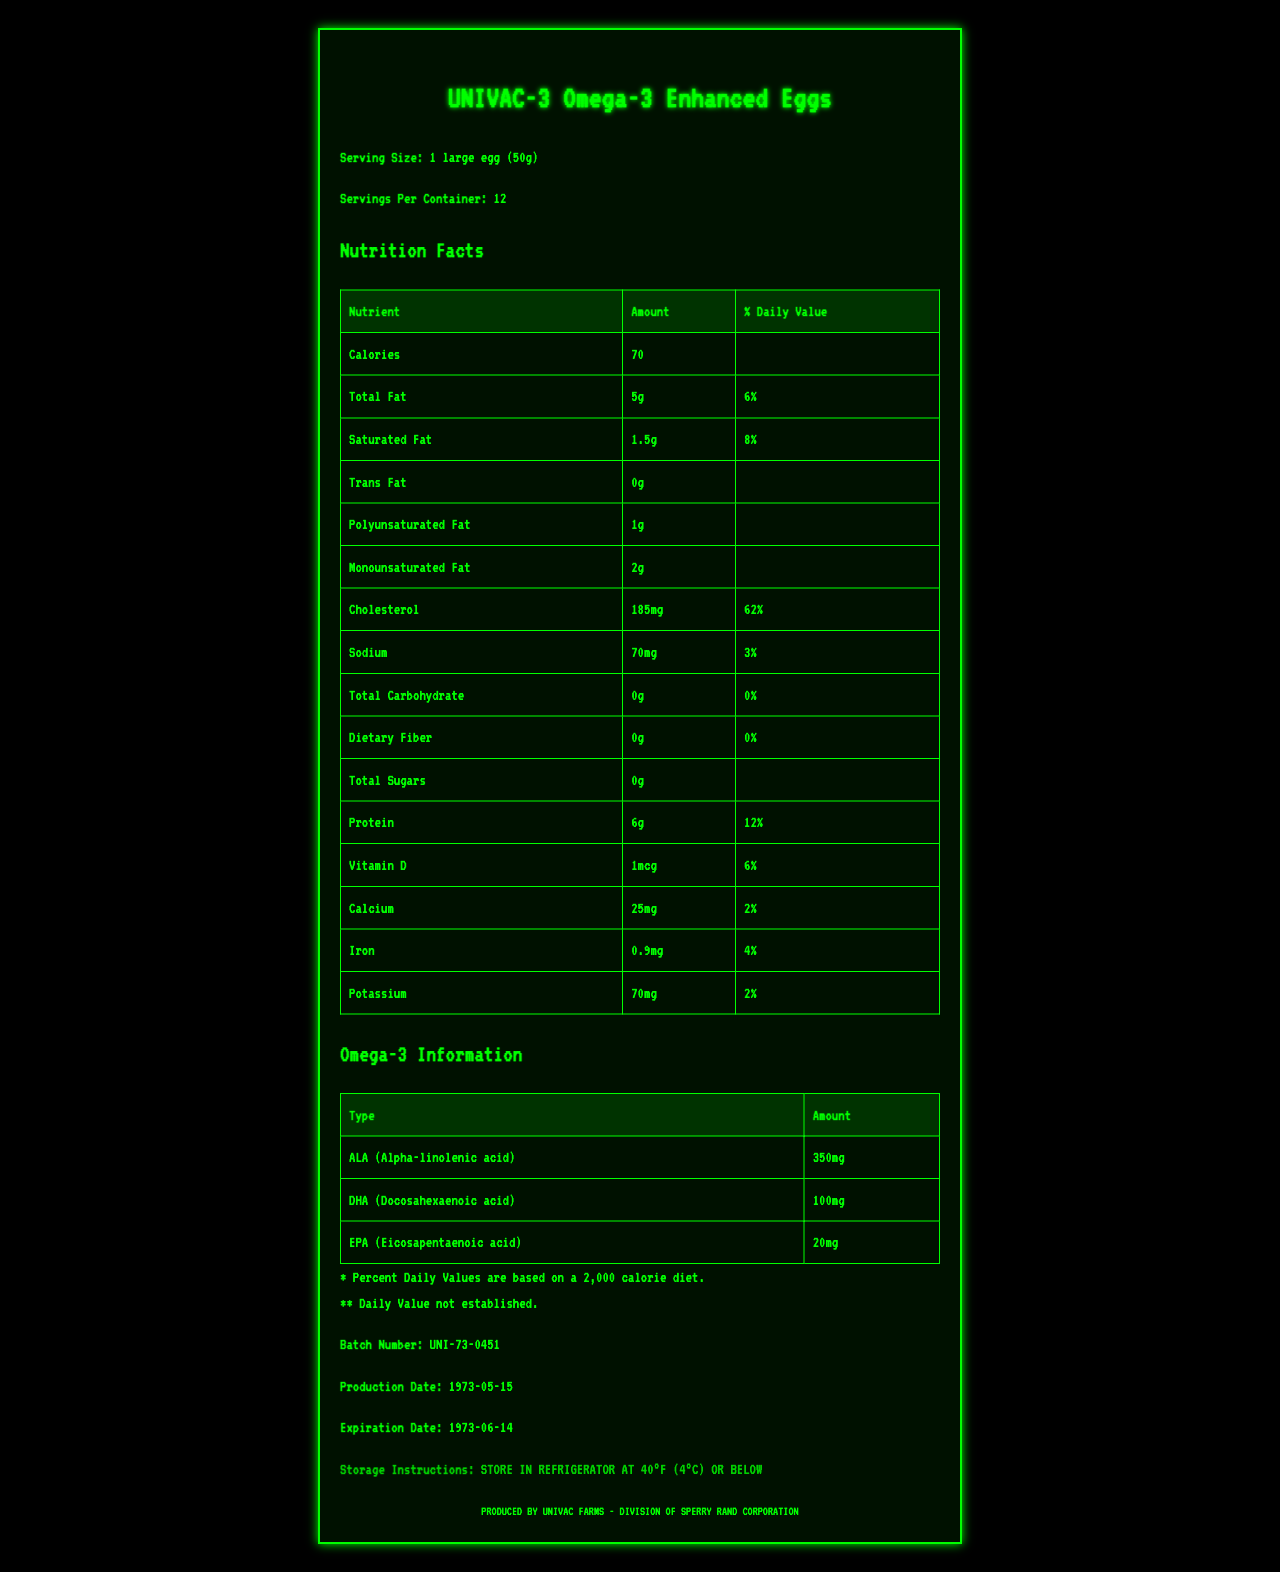what is the serving size of UNIVAC-3 Omega-3 Enhanced Eggs? The serving size is explicitly mentioned under the product name near the top of the document.
Answer: 1 large egg (50g) how many servings are there per container? The number of servings per container is listed below the serving size in the document.
Answer: 12 how many calories are there in one serving? The calorie content per serving is mentioned in the Nutrition Facts section of the document.
Answer: 70 what is the percentage daily value of cholesterol in one serving? The percent daily value of cholesterol is listed under the 'Cholesterol' entry in the Nutrition Facts section.
Answer: 62% what is the total amount of protein in a serving? The protein amount per serving is provided in the Nutrition Facts section.
Answer: 6g which of the following is NOT a type of Omega-3 mentioned in the document? 1. ALA 2. CLA 3. DHA 4. EPA The Omega-3 Information section only lists ALA (Alpha-linolenic acid), DHA (Docosahexaenoic acid), and EPA (Eicosapentaenoic acid).
Answer: 2. CLA how much Vitamin D is present in one serving? The Vitamin D amount is listed under the Nutrition Facts section.
Answer: 1mcg what is the production date of the batch? The production date is clearly stated near the end of the document under the Batch Number and Expiration Date section.
Answer: 1973-05-15 which nutrient has the highest percent daily value? A. Sodium B. Iron C. Protein D. Cholesterol Cholesterol has a percent daily value of 62%, the highest among all nutrients listed.
Answer: D. Cholesterol is there any Trans Fat in one serving? The document lists '0g' next to Trans Fat in the Nutrition Facts section, indicating there is no Trans Fat.
Answer: No summarize the main idea of the document The summary covers key elements like nutritional facts, omega-3 content, serving details, and storage instructions presented in an old-school format.
Answer: The document provides detailed nutritional information for UNIVAC-3 Omega-3 Enhanced Eggs, including serving size, nutritional content, omega-3 information, and storage instructions, presented in a vintage computer printout style. what is the baseline for the percent daily values described in the document? The footnote at the bottom of the document states that Percent Daily Values are based on a 2,000 calorie diet.
Answer: 2,000 calorie diet how much calcium is in one serving? The Nutrition Facts section lists the amount of calcium in one serving.
Answer: 25mg can this document tell you the cost of the eggs? The document does not provide any pricing information or cost details.
Answer: Not enough information 